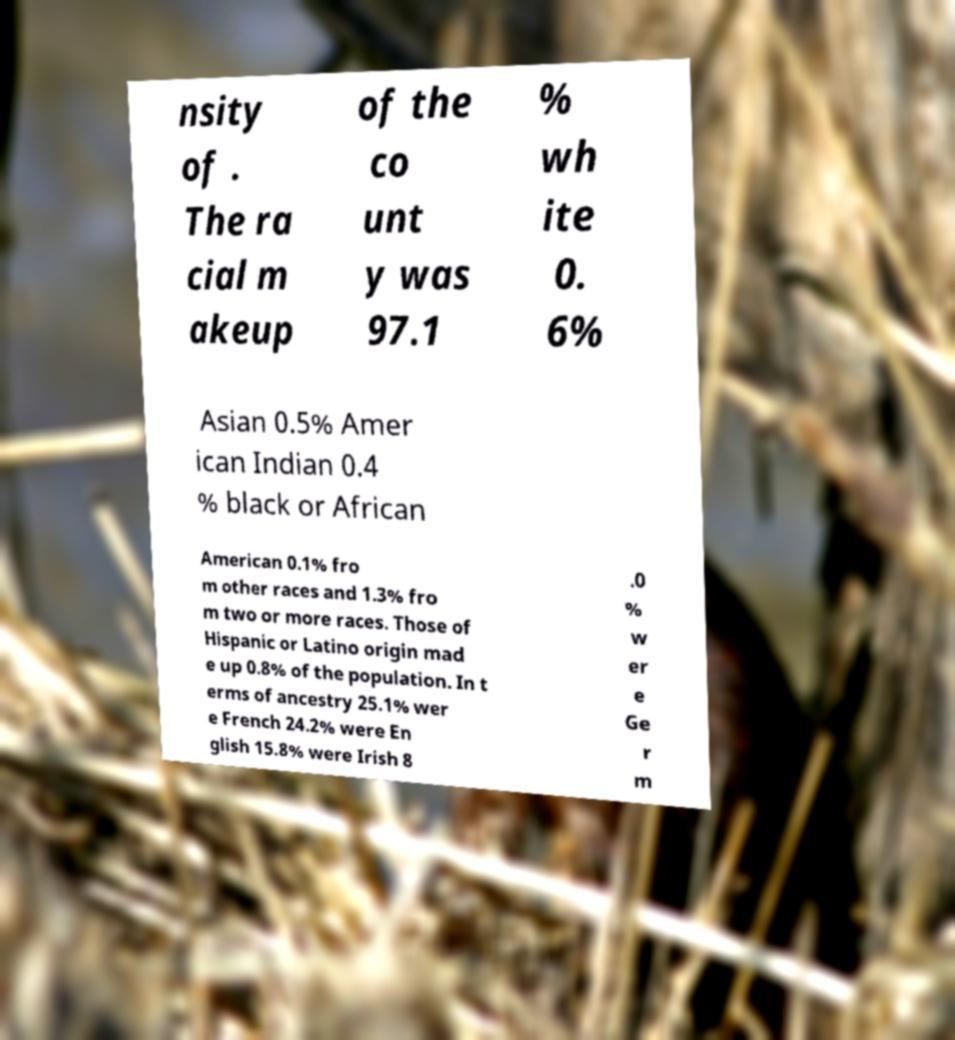Could you assist in decoding the text presented in this image and type it out clearly? nsity of . The ra cial m akeup of the co unt y was 97.1 % wh ite 0. 6% Asian 0.5% Amer ican Indian 0.4 % black or African American 0.1% fro m other races and 1.3% fro m two or more races. Those of Hispanic or Latino origin mad e up 0.8% of the population. In t erms of ancestry 25.1% wer e French 24.2% were En glish 15.8% were Irish 8 .0 % w er e Ge r m 